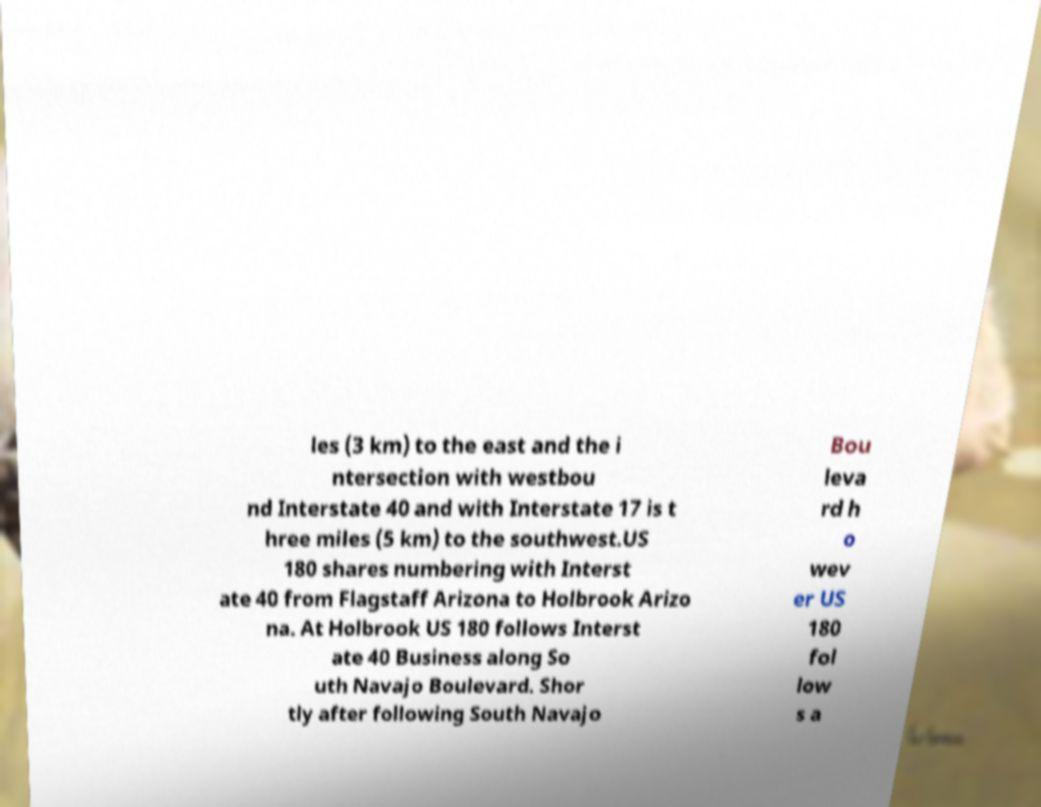There's text embedded in this image that I need extracted. Can you transcribe it verbatim? les (3 km) to the east and the i ntersection with westbou nd Interstate 40 and with Interstate 17 is t hree miles (5 km) to the southwest.US 180 shares numbering with Interst ate 40 from Flagstaff Arizona to Holbrook Arizo na. At Holbrook US 180 follows Interst ate 40 Business along So uth Navajo Boulevard. Shor tly after following South Navajo Bou leva rd h o wev er US 180 fol low s a 